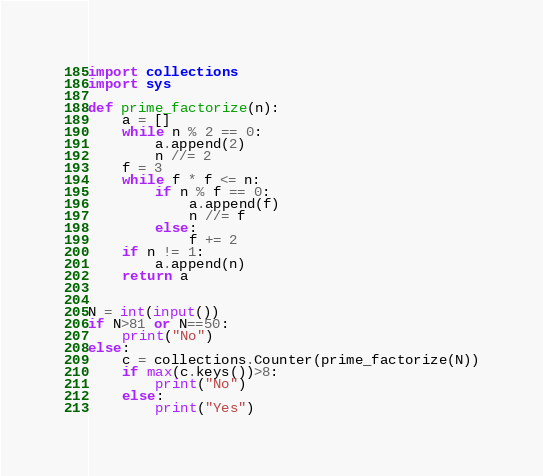<code> <loc_0><loc_0><loc_500><loc_500><_Python_>import collections
import sys

def prime_factorize(n):
    a = []
    while n % 2 == 0:
        a.append(2)
        n //= 2
    f = 3
    while f * f <= n:
        if n % f == 0:
            a.append(f)
            n //= f
        else:
            f += 2
    if n != 1:
        a.append(n)
    return a


N = int(input())
if N>81 or N==50:
  	print("No")
else:
  	c = collections.Counter(prime_factorize(N))
   	if max(c.keys())>8:
    	print("No")
  	else:
        print("Yes")</code> 